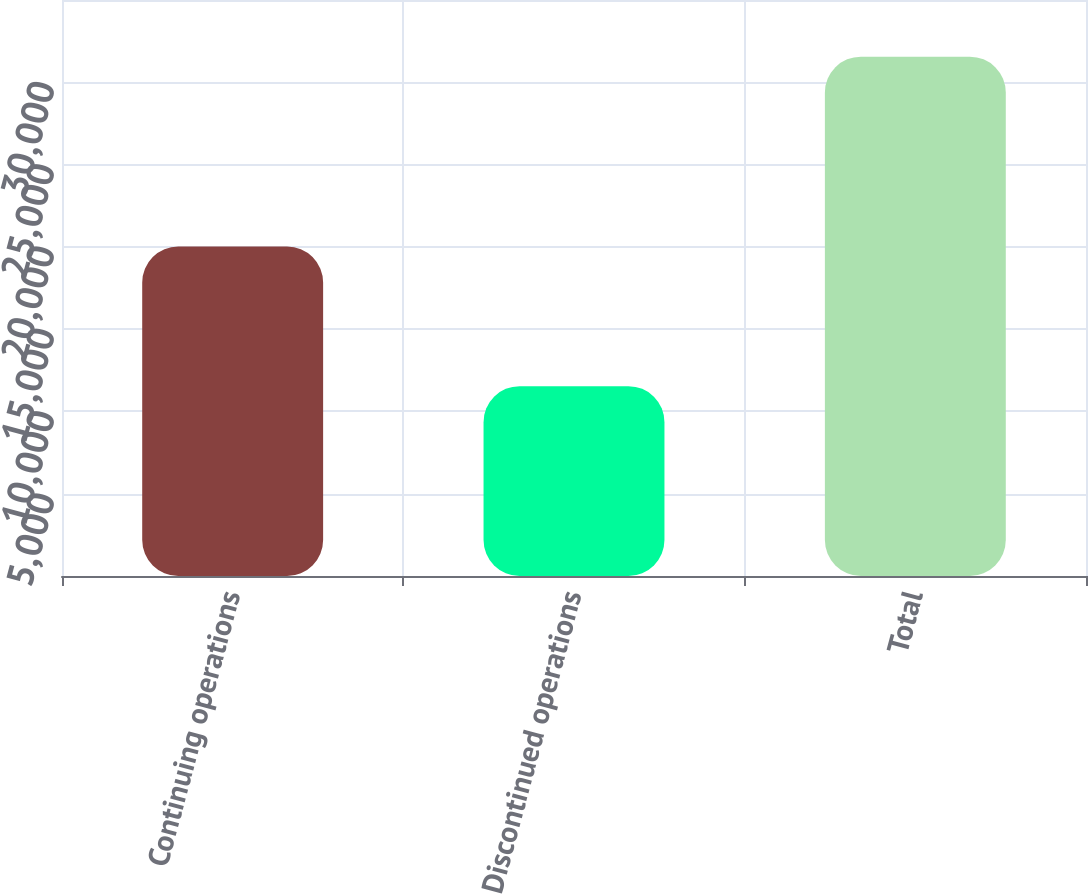Convert chart to OTSL. <chart><loc_0><loc_0><loc_500><loc_500><bar_chart><fcel>Continuing operations<fcel>Discontinued operations<fcel>Total<nl><fcel>20022<fcel>11537<fcel>31559<nl></chart> 